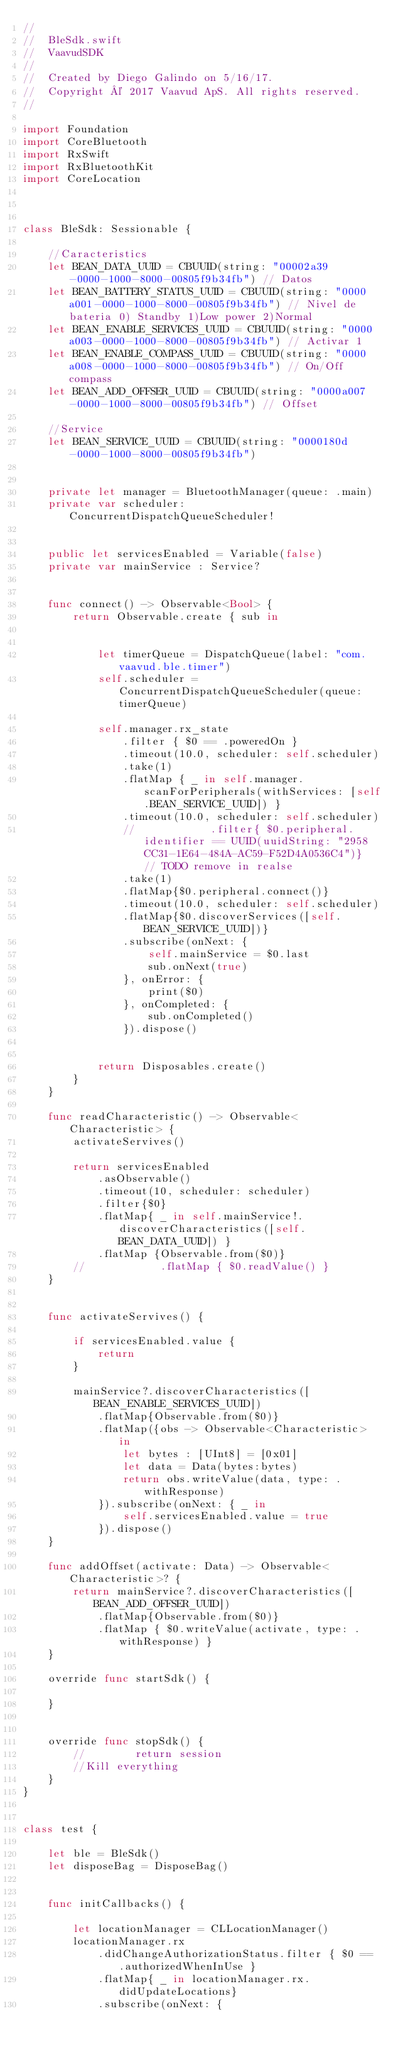Convert code to text. <code><loc_0><loc_0><loc_500><loc_500><_Swift_>//
//  BleSdk.swift
//  VaavudSDK
//
//  Created by Diego Galindo on 5/16/17.
//  Copyright © 2017 Vaavud ApS. All rights reserved.
//

import Foundation
import CoreBluetooth
import RxSwift
import RxBluetoothKit
import CoreLocation



class BleSdk: Sessionable {
    
    //Caracteristics
    let BEAN_DATA_UUID = CBUUID(string: "00002a39-0000-1000-8000-00805f9b34fb") // Datos
    let BEAN_BATTERY_STATUS_UUID = CBUUID(string: "0000a001-0000-1000-8000-00805f9b34fb") // Nivel de bateria 0) Standby 1)Low power 2)Normal
    let BEAN_ENABLE_SERVICES_UUID = CBUUID(string: "0000a003-0000-1000-8000-00805f9b34fb") // Activar 1
    let BEAN_ENABLE_COMPASS_UUID = CBUUID(string: "0000a008-0000-1000-8000-00805f9b34fb") // On/Off compass
    let BEAN_ADD_OFFSER_UUID = CBUUID(string: "0000a007-0000-1000-8000-00805f9b34fb") // Offset
    
    //Service
    let BEAN_SERVICE_UUID = CBUUID(string: "0000180d-0000-1000-8000-00805f9b34fb")
    
    
    private let manager = BluetoothManager(queue: .main)
    private var scheduler: ConcurrentDispatchQueueScheduler!
    
    
    public let servicesEnabled = Variable(false)
    private var mainService : Service?
    
    
    func connect() -> Observable<Bool> {
        return Observable.create { sub in
            
            
            let timerQueue = DispatchQueue(label: "com.vaavud.ble.timer")
            self.scheduler = ConcurrentDispatchQueueScheduler(queue:timerQueue)
            
            self.manager.rx_state
                .filter { $0 == .poweredOn }
                .timeout(10.0, scheduler: self.scheduler)
                .take(1)
                .flatMap { _ in self.manager.scanForPeripherals(withServices: [self.BEAN_SERVICE_UUID]) }
                .timeout(10.0, scheduler: self.scheduler)
                //            .filter{ $0.peripheral.identifier == UUID(uuidString: "2958CC31-1E64-484A-AC59-F52D4A0536C4")}  // TODO remove in realse
                .take(1)
                .flatMap{$0.peripheral.connect()}
                .timeout(10.0, scheduler: self.scheduler)
                .flatMap{$0.discoverServices([self.BEAN_SERVICE_UUID])}
                .subscribe(onNext: {
                    self.mainService = $0.last
                    sub.onNext(true)
                }, onError: {
                    print($0)
                }, onCompleted: {
                    sub.onCompleted()
                }).dispose()
            
            
            return Disposables.create()
        }
    }
    
    func readCharacteristic() -> Observable<Characteristic> {
        activateServives()
        
        return servicesEnabled
            .asObservable()
            .timeout(10, scheduler: scheduler)
            .filter{$0}
            .flatMap{ _ in self.mainService!.discoverCharacteristics([self.BEAN_DATA_UUID]) }
            .flatMap {Observable.from($0)}
        //            .flatMap { $0.readValue() }
    }
    
    
    func activateServives() {
        
        if servicesEnabled.value {
            return
        }
        
        mainService?.discoverCharacteristics([BEAN_ENABLE_SERVICES_UUID])
            .flatMap{Observable.from($0)}
            .flatMap({obs -> Observable<Characteristic> in
                let bytes : [UInt8] = [0x01]
                let data = Data(bytes:bytes)
                return obs.writeValue(data, type: .withResponse)
            }).subscribe(onNext: { _ in
                self.servicesEnabled.value = true
            }).dispose()
    }
    
    func addOffset(activate: Data) -> Observable<Characteristic>? {
        return mainService?.discoverCharacteristics([BEAN_ADD_OFFSER_UUID])
            .flatMap{Observable.from($0)}
            .flatMap { $0.writeValue(activate, type: .withResponse) }
    }
    
    override func startSdk() {
        
    }
    
    
    override func stopSdk() {
        //        return session
        //Kill everything
    }
}


class test {
    
    let ble = BleSdk()
    let disposeBag = DisposeBag()
    
    
    func initCallbacks() {
        
        let locationManager = CLLocationManager()
        locationManager.rx
            .didChangeAuthorizationStatus.filter { $0 == .authorizedWhenInUse }
            .flatMap{ _ in locationManager.rx.didUpdateLocations}
            .subscribe(onNext: {</code> 